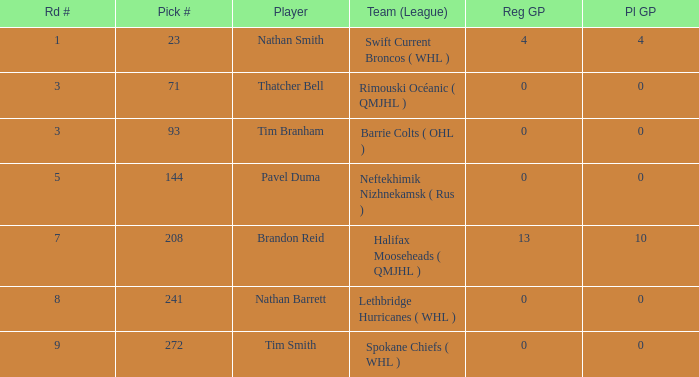What is the number of reg gp for nathan barrett in a round fewer than 8? 0.0. 